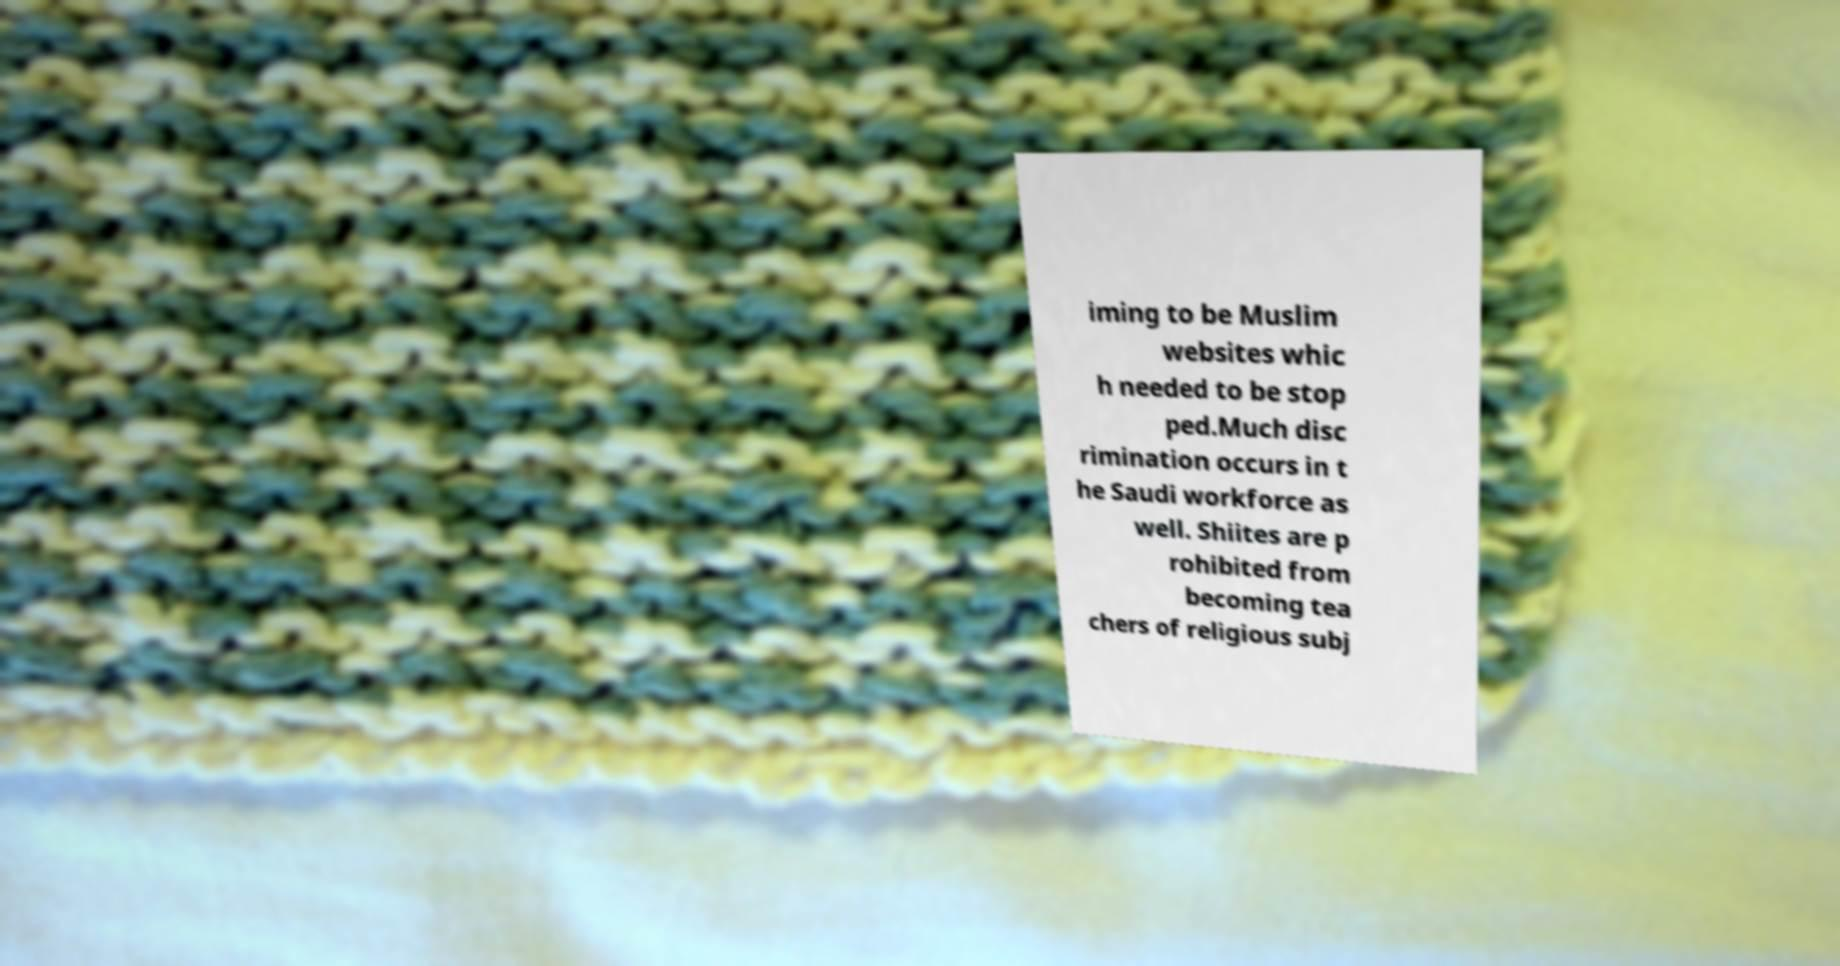Can you read and provide the text displayed in the image?This photo seems to have some interesting text. Can you extract and type it out for me? iming to be Muslim websites whic h needed to be stop ped.Much disc rimination occurs in t he Saudi workforce as well. Shiites are p rohibited from becoming tea chers of religious subj 